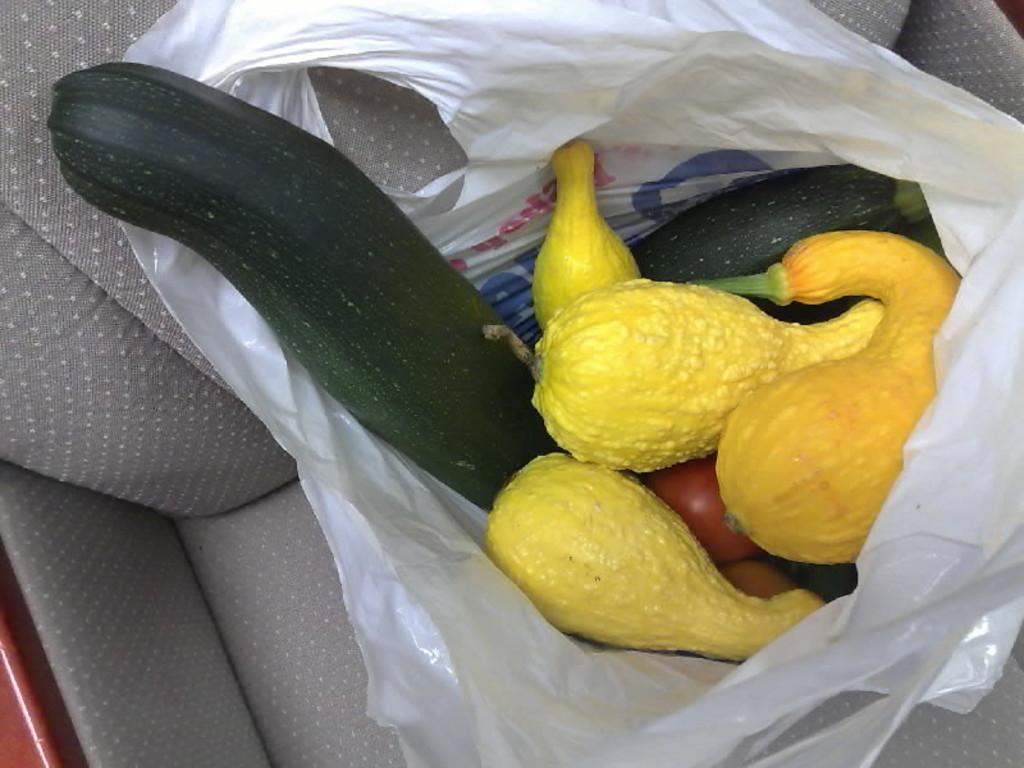What object is located at the bottom of the image? There is a chair at the bottom of the image. What is on the chair? There is a white color bag on the chair. What is inside the bag? The bag contains vegetables. How does the chair control the son's breath in the image? There is no son or reference to breath control in the image; it only features a chair with a white color bag containing vegetables. 